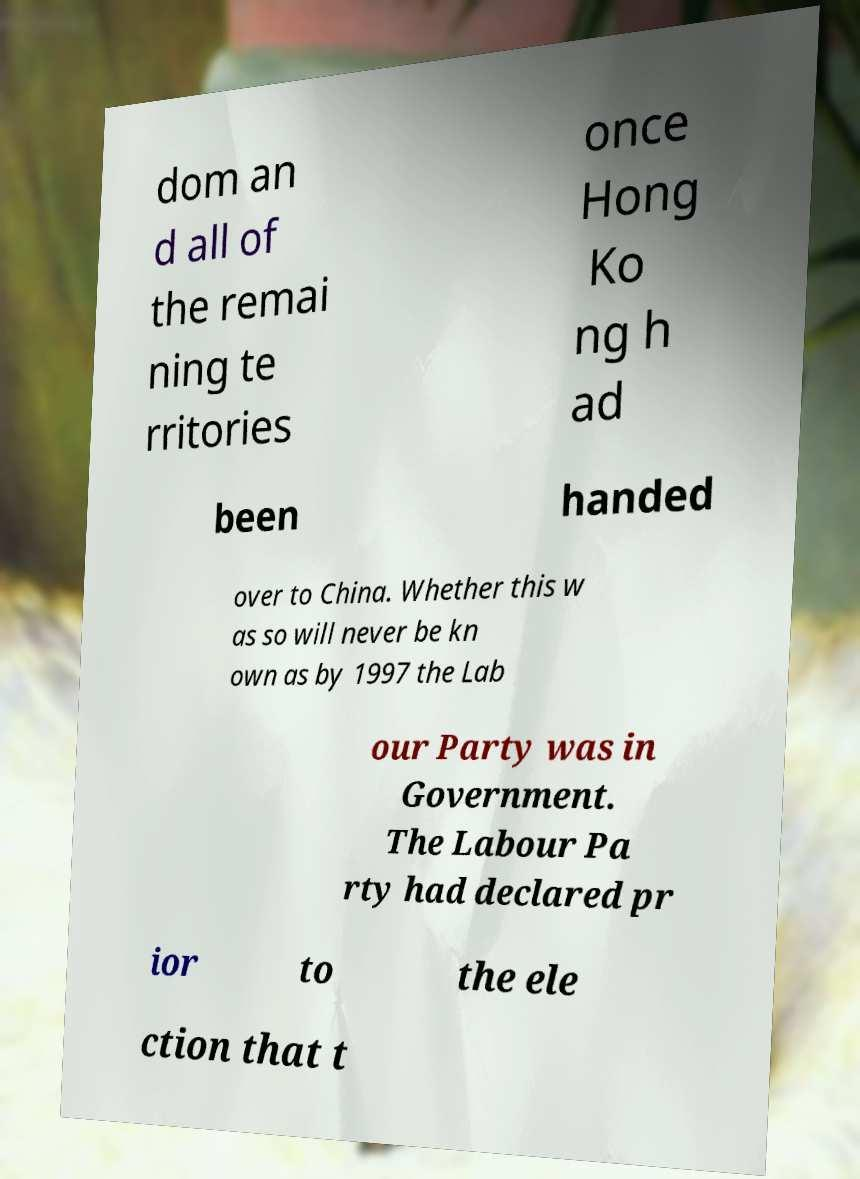Can you read and provide the text displayed in the image?This photo seems to have some interesting text. Can you extract and type it out for me? dom an d all of the remai ning te rritories once Hong Ko ng h ad been handed over to China. Whether this w as so will never be kn own as by 1997 the Lab our Party was in Government. The Labour Pa rty had declared pr ior to the ele ction that t 